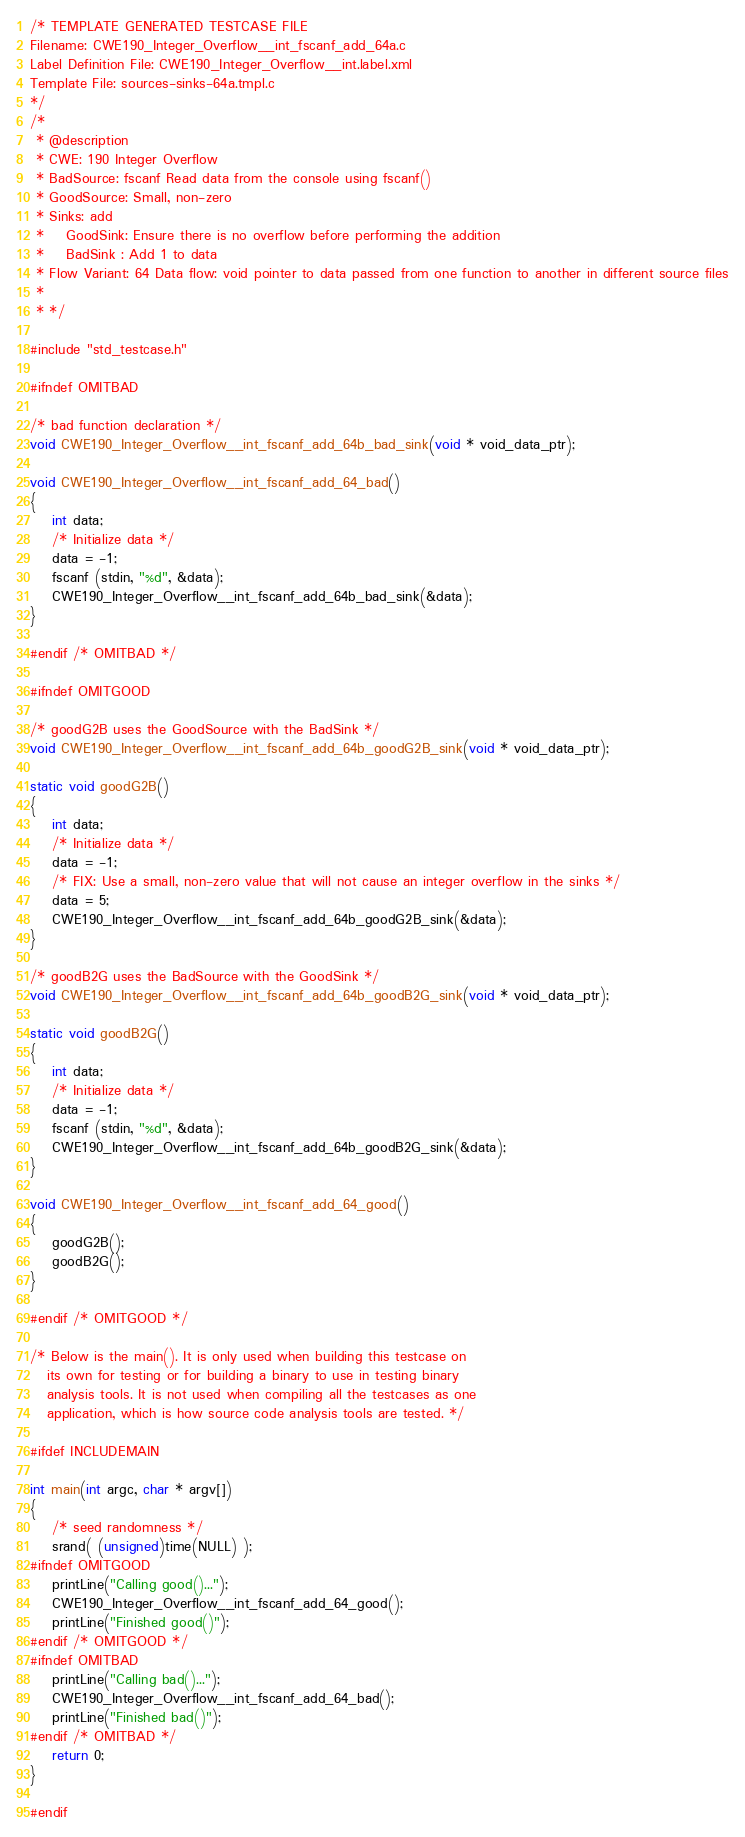<code> <loc_0><loc_0><loc_500><loc_500><_C_>/* TEMPLATE GENERATED TESTCASE FILE
Filename: CWE190_Integer_Overflow__int_fscanf_add_64a.c
Label Definition File: CWE190_Integer_Overflow__int.label.xml
Template File: sources-sinks-64a.tmpl.c
*/
/*
 * @description
 * CWE: 190 Integer Overflow
 * BadSource: fscanf Read data from the console using fscanf()
 * GoodSource: Small, non-zero
 * Sinks: add
 *    GoodSink: Ensure there is no overflow before performing the addition
 *    BadSink : Add 1 to data
 * Flow Variant: 64 Data flow: void pointer to data passed from one function to another in different source files
 *
 * */

#include "std_testcase.h"

#ifndef OMITBAD

/* bad function declaration */
void CWE190_Integer_Overflow__int_fscanf_add_64b_bad_sink(void * void_data_ptr);

void CWE190_Integer_Overflow__int_fscanf_add_64_bad()
{
    int data;
    /* Initialize data */
    data = -1;
    fscanf (stdin, "%d", &data);
    CWE190_Integer_Overflow__int_fscanf_add_64b_bad_sink(&data);
}

#endif /* OMITBAD */

#ifndef OMITGOOD

/* goodG2B uses the GoodSource with the BadSink */
void CWE190_Integer_Overflow__int_fscanf_add_64b_goodG2B_sink(void * void_data_ptr);

static void goodG2B()
{
    int data;
    /* Initialize data */
    data = -1;
    /* FIX: Use a small, non-zero value that will not cause an integer overflow in the sinks */
    data = 5;
    CWE190_Integer_Overflow__int_fscanf_add_64b_goodG2B_sink(&data);
}

/* goodB2G uses the BadSource with the GoodSink */
void CWE190_Integer_Overflow__int_fscanf_add_64b_goodB2G_sink(void * void_data_ptr);

static void goodB2G()
{
    int data;
    /* Initialize data */
    data = -1;
    fscanf (stdin, "%d", &data);
    CWE190_Integer_Overflow__int_fscanf_add_64b_goodB2G_sink(&data);
}

void CWE190_Integer_Overflow__int_fscanf_add_64_good()
{
    goodG2B();
    goodB2G();
}

#endif /* OMITGOOD */

/* Below is the main(). It is only used when building this testcase on
   its own for testing or for building a binary to use in testing binary
   analysis tools. It is not used when compiling all the testcases as one
   application, which is how source code analysis tools are tested. */

#ifdef INCLUDEMAIN

int main(int argc, char * argv[])
{
    /* seed randomness */
    srand( (unsigned)time(NULL) );
#ifndef OMITGOOD
    printLine("Calling good()...");
    CWE190_Integer_Overflow__int_fscanf_add_64_good();
    printLine("Finished good()");
#endif /* OMITGOOD */
#ifndef OMITBAD
    printLine("Calling bad()...");
    CWE190_Integer_Overflow__int_fscanf_add_64_bad();
    printLine("Finished bad()");
#endif /* OMITBAD */
    return 0;
}

#endif
</code> 